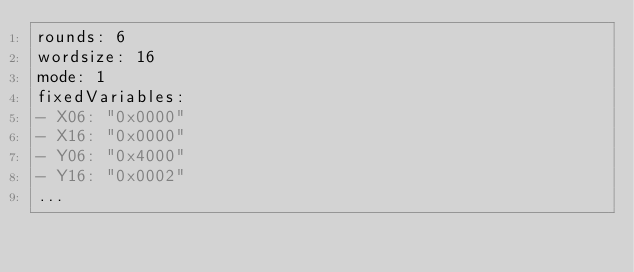<code> <loc_0><loc_0><loc_500><loc_500><_YAML_>rounds: 6
wordsize: 16
mode: 1
fixedVariables:
- X06: "0x0000"
- X16: "0x0000"
- Y06: "0x4000"
- Y16: "0x0002"
...

</code> 